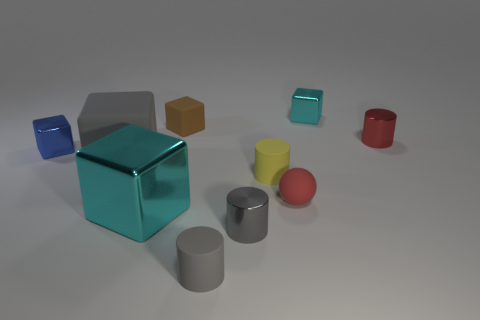How do the objects in this image appear to be arranged? The objects are arranged in a seemingly random, scattered pattern across a flat surface with sufficient space between them, which allows each item to stand out on its own. The position of the objects does not seem to follow any particular order or structure, suggesting a casual placement without a deliberate attempt to create symmetry or alignment. 